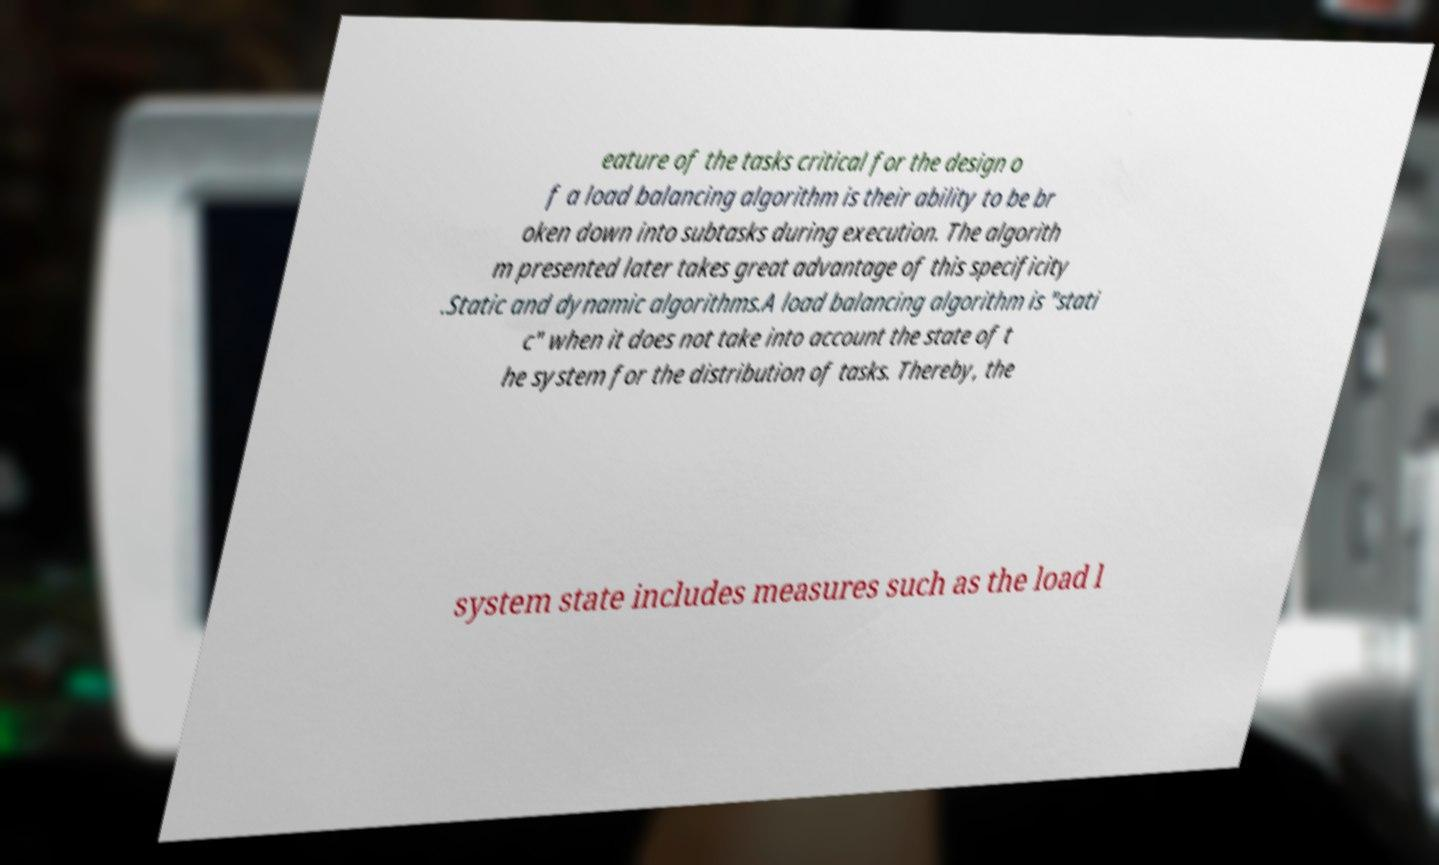What messages or text are displayed in this image? I need them in a readable, typed format. eature of the tasks critical for the design o f a load balancing algorithm is their ability to be br oken down into subtasks during execution. The algorith m presented later takes great advantage of this specificity .Static and dynamic algorithms.A load balancing algorithm is "stati c" when it does not take into account the state of t he system for the distribution of tasks. Thereby, the system state includes measures such as the load l 